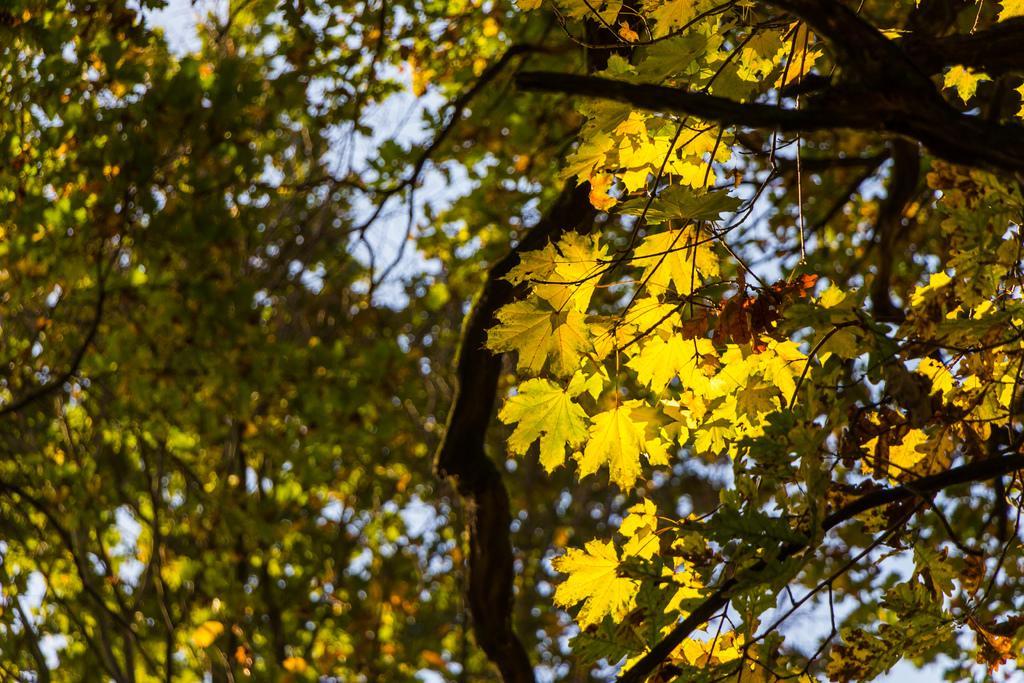Please provide a concise description of this image. In this picture we can see few trees. 